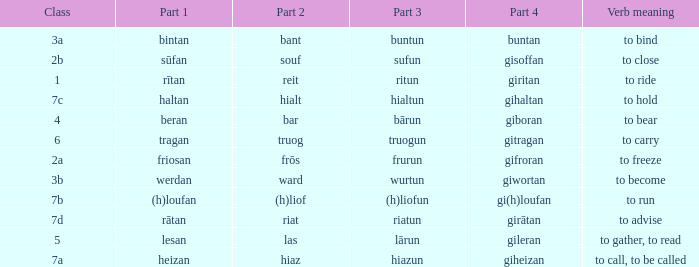What is the verb meaning of the word with part 2 "bant"? To bind. 